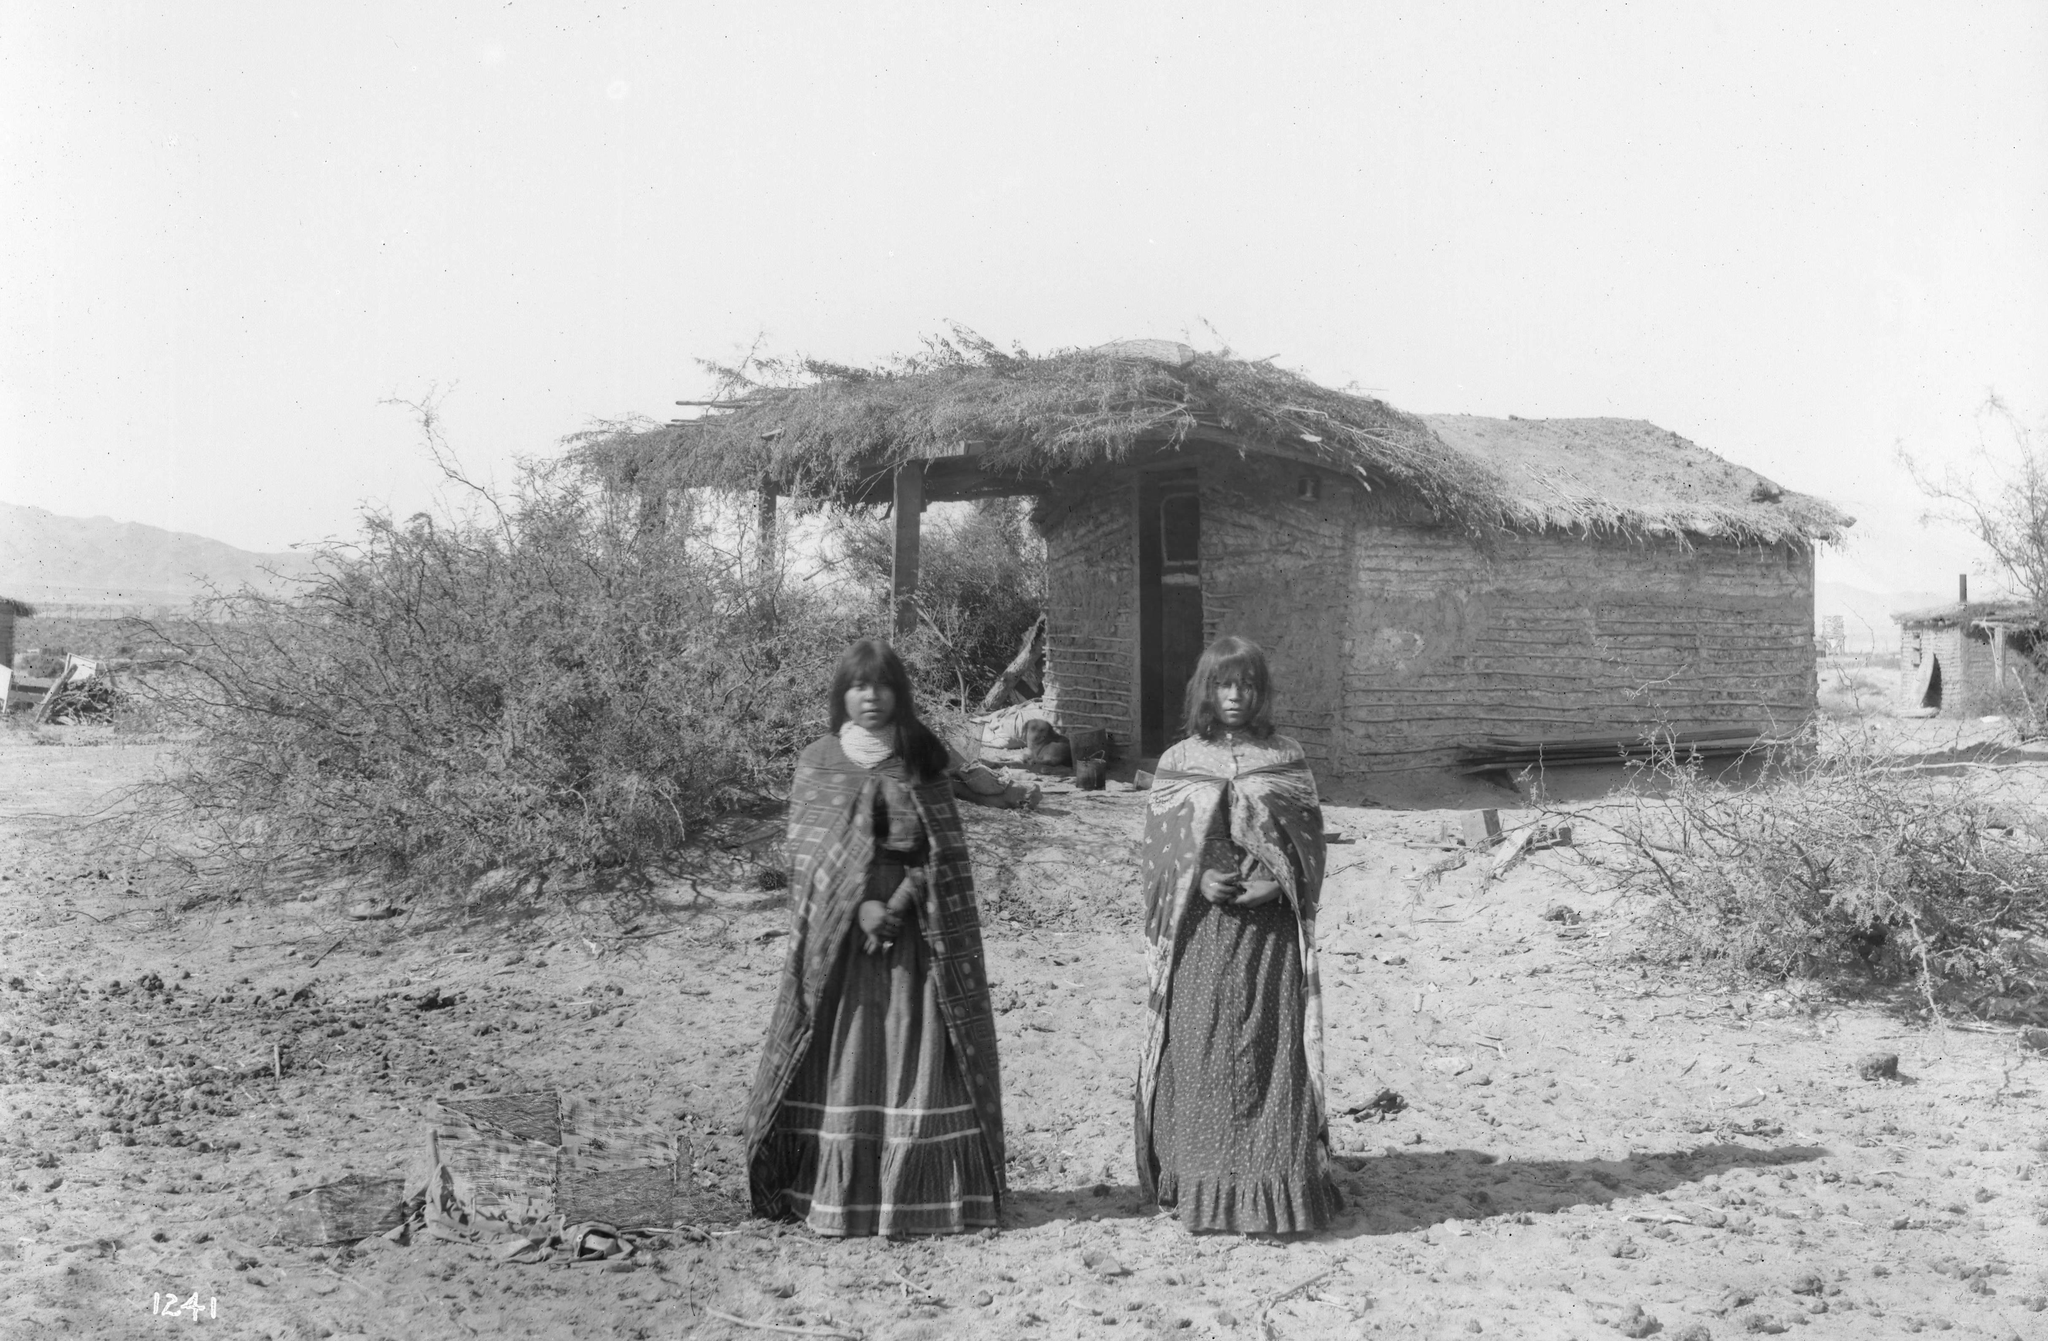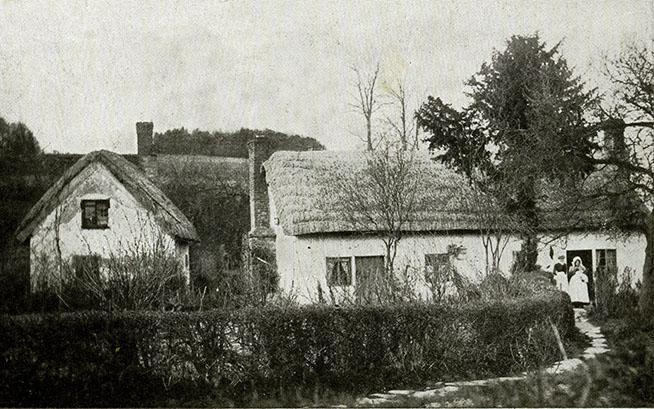The first image is the image on the left, the second image is the image on the right. Assess this claim about the two images: "The right image features palm trees behind at least one primitive structure with a peaked thatch roof.". Correct or not? Answer yes or no. No. 